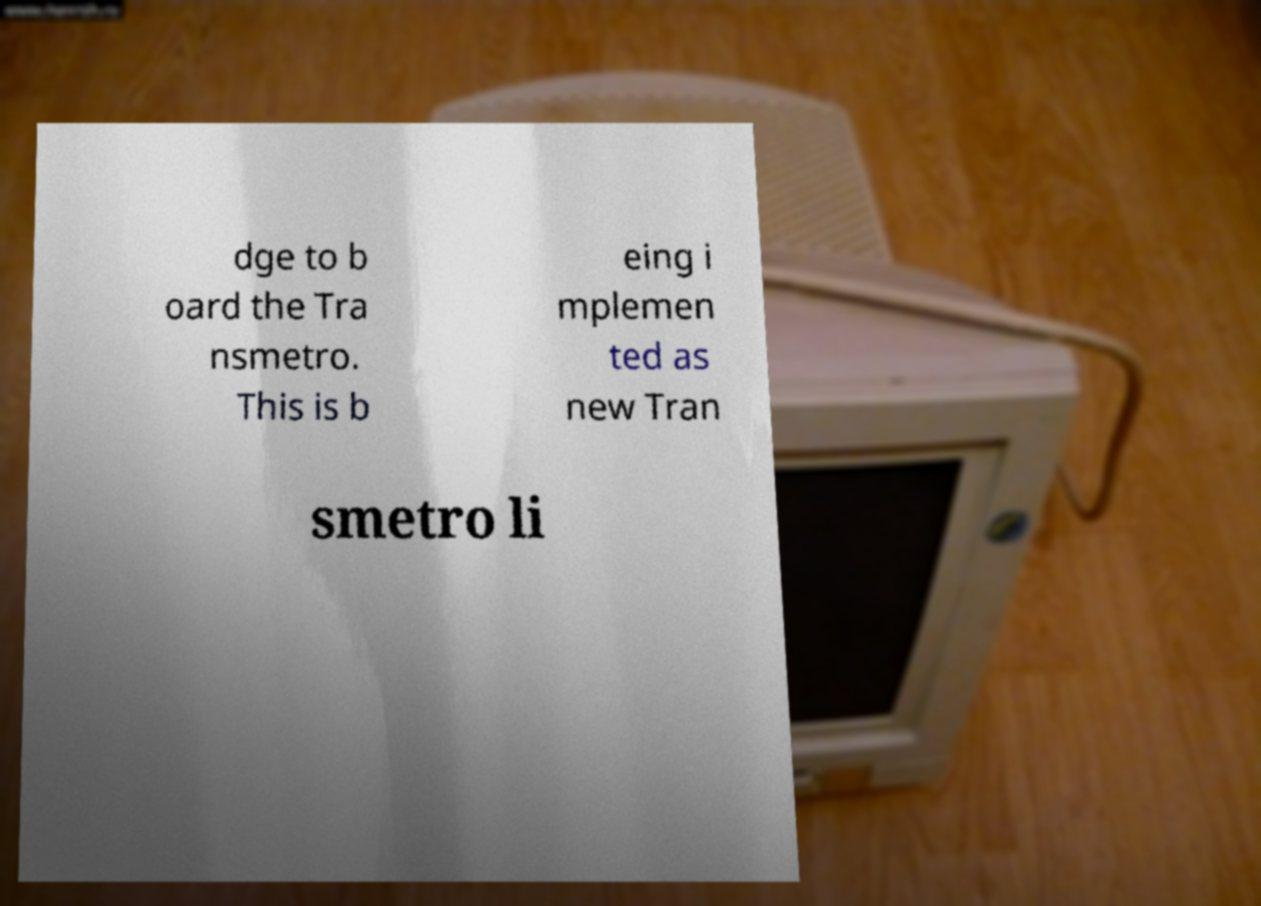Please identify and transcribe the text found in this image. dge to b oard the Tra nsmetro. This is b eing i mplemen ted as new Tran smetro li 